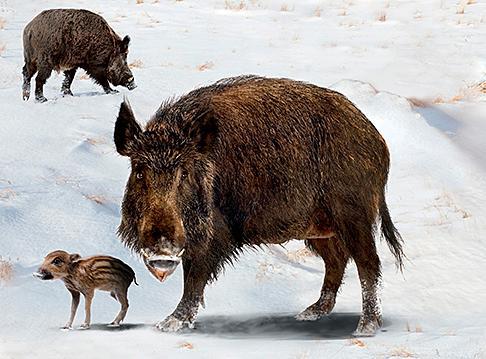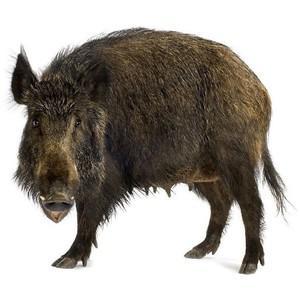The first image is the image on the left, the second image is the image on the right. Considering the images on both sides, is "A single wild pig is in the snow in each of the images." valid? Answer yes or no. No. 